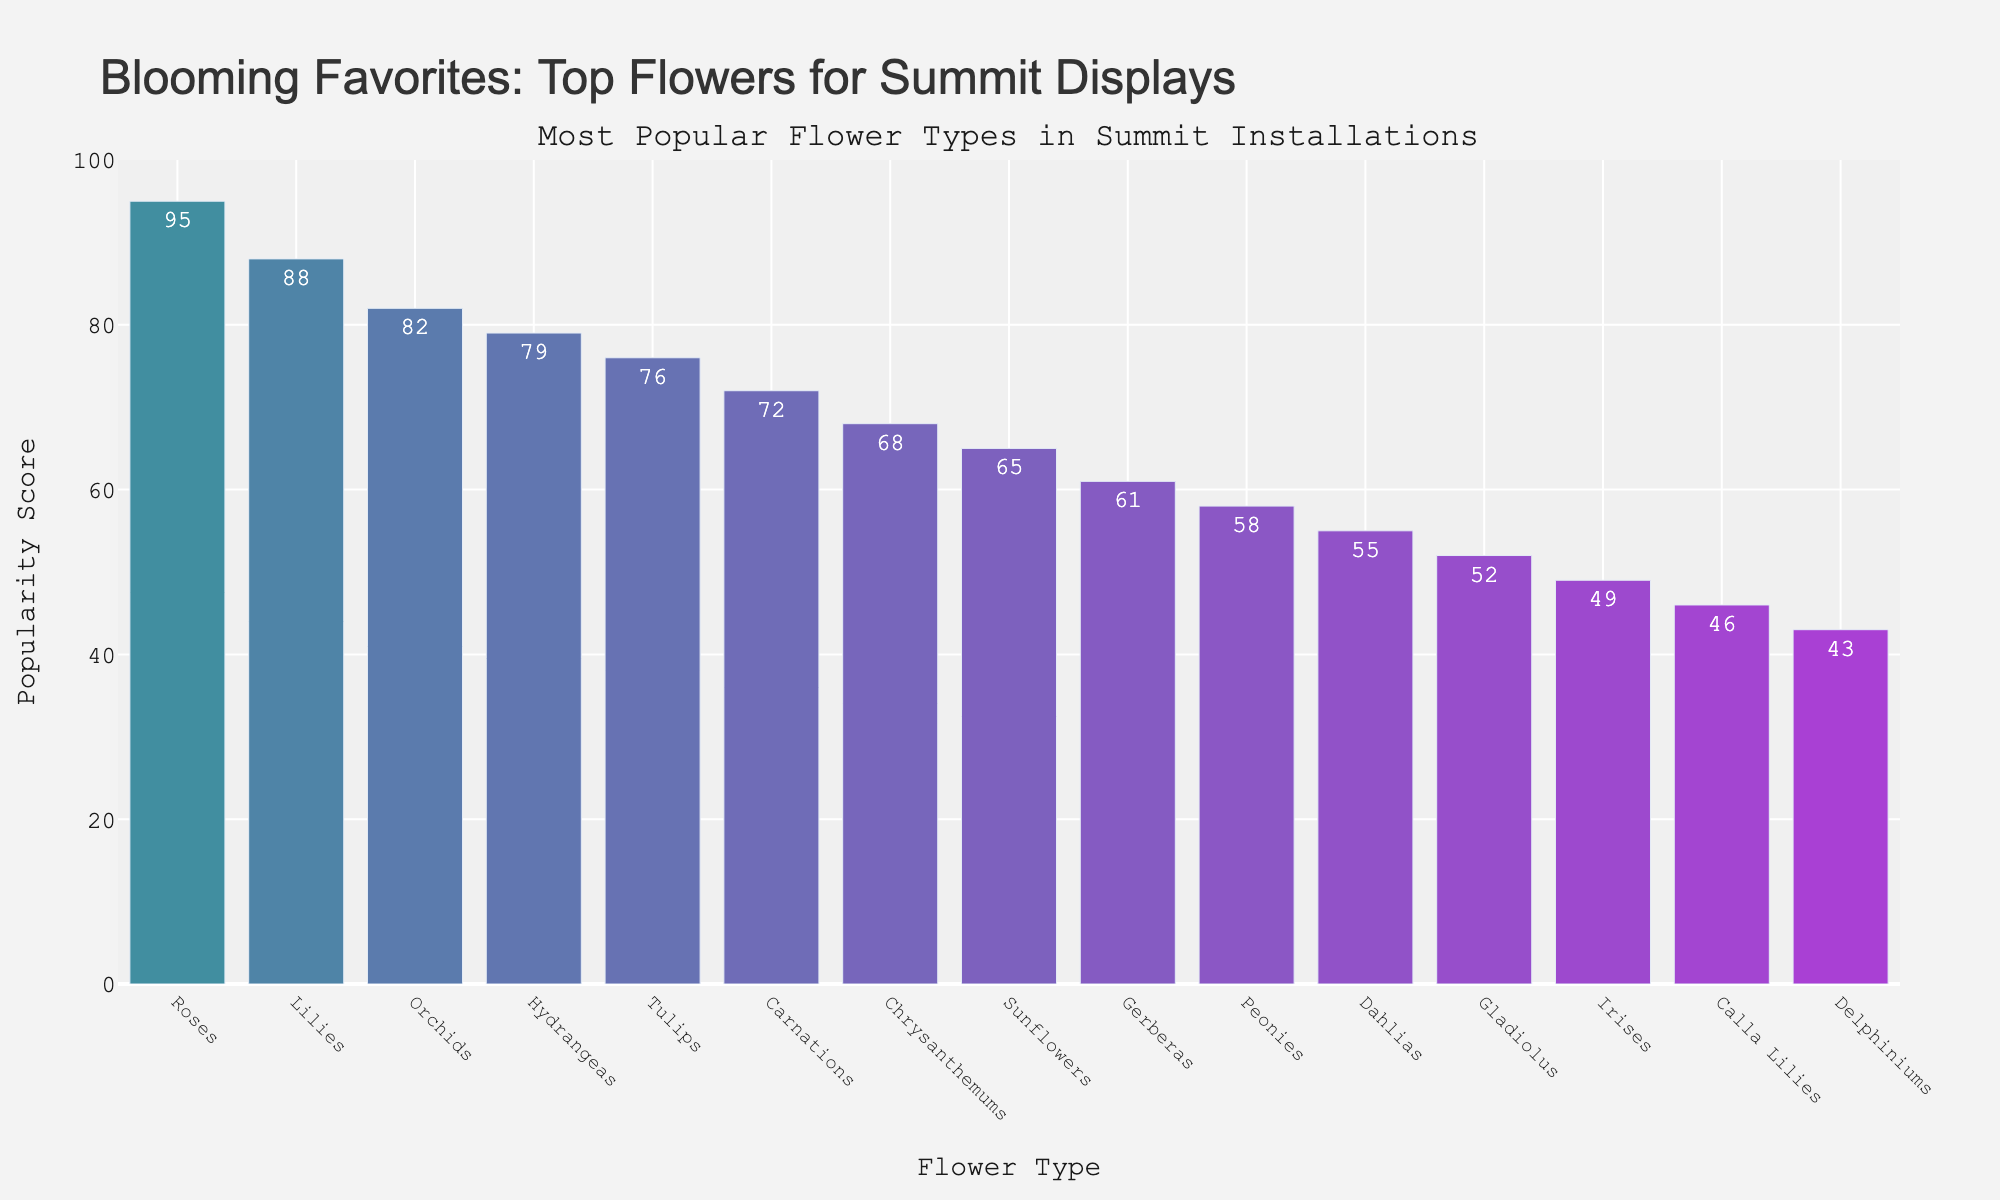Which flower type has the highest popularity score? The figure shows multiple flower types ranked by their popularity score. The highest bar represents the most popular flower type. The tallest bar is for Roses, with a popularity score of 95.
Answer: Roses What is the difference in popularity scores between Roses and Tulips? To find the difference, subtract the popularity score of Tulips from the popularity score of Roses. Roses have a score of 95, and Tulips have a score of 76. So, 95 - 76 = 19.
Answer: 19 Which flower type is more popular: Hydrangeas or Peonies? By comparing the heights of the bars for Hydrangeas and Peonies, we see that Hydrangeas have a higher bar, indicating a popularity score of 79 compared to Peonies' 58.
Answer: Hydrangeas What is the average popularity score of the top five most popular flower types? To find the average, sum the popularity scores of the top five flower types and divide by 5. The top five are Roses (95), Lilies (88), Orchids (82), Hydrangeas (79), and Tulips (76). Sum: 95 + 88 + 82 + 79 + 76 = 420. Average: 420 / 5 = 84.
Answer: 84 How many flower types have a popularity score greater than 60? Count the bars that have a height corresponding to a popularity score greater than 60. These flower types are Roses (95), Lilies (88), Orchids (82), Hydrangeas (79), Tulips (76), Carnations (72), Chrysanthemums (68), and Sunflowers (65), making a total of 8.
Answer: 8 Which flower type has the lowest popularity score? The figure shows multiple flower types ranked by their popularity score. The shortest bar represents the least popular flower type. The shortest bar is for Delphiniums, with a popularity score of 43.
Answer: Delphiniums What is the combined popularity score of Sunflowers and Gerberas? Sum the popularity scores of Sunflowers and Gerberas. Sunflowers have a score of 65, and Gerberas have a score of 61. So, 65 + 61 = 126.
Answer: 126 How does the popularity of Dahlias compare to that of Gladiolus? By comparing the heights of the bars for Dahlias and Gladiolus, we see that Dahlias have a higher bar, indicating a popularity score of 55 compared to Gladiolus' 52.
Answer: Dahlias What is the range of popularity scores for the displayed flower types? Identify the highest and lowest popularity scores and calculate the range by subtracting the lowest from the highest. The highest is 95 (Roses) and the lowest is 43 (Delphiniums), so the range is 95 - 43 = 52.
Answer: 52 